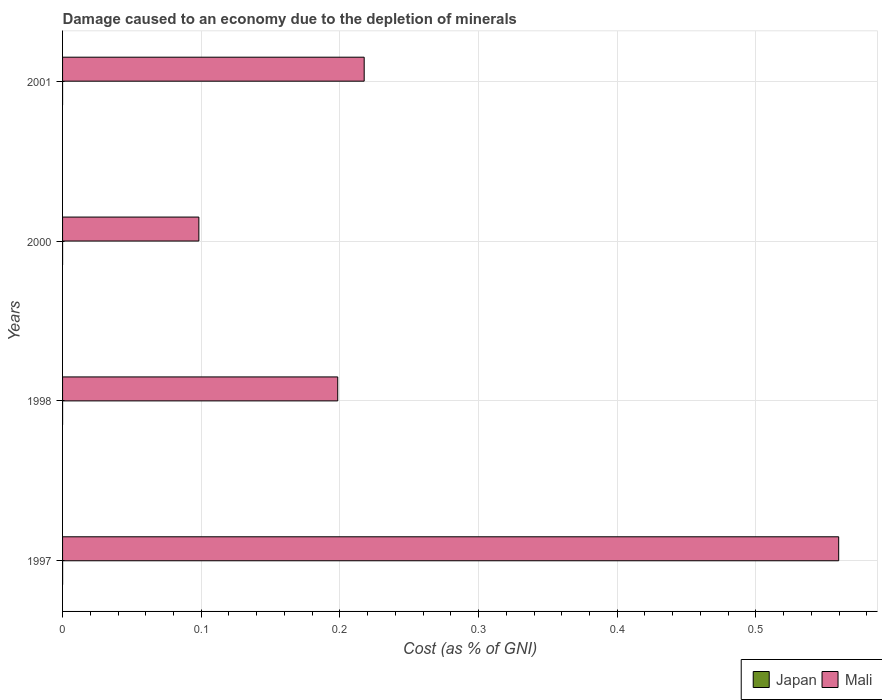How many groups of bars are there?
Your answer should be very brief. 4. Are the number of bars per tick equal to the number of legend labels?
Make the answer very short. Yes. What is the label of the 2nd group of bars from the top?
Your answer should be compact. 2000. What is the cost of damage caused due to the depletion of minerals in Japan in 1998?
Your answer should be very brief. 5.083030535406881e-6. Across all years, what is the maximum cost of damage caused due to the depletion of minerals in Japan?
Keep it short and to the point. 3.11135338085447e-5. Across all years, what is the minimum cost of damage caused due to the depletion of minerals in Japan?
Ensure brevity in your answer.  3.07197068481152e-6. In which year was the cost of damage caused due to the depletion of minerals in Mali maximum?
Provide a short and direct response. 1997. In which year was the cost of damage caused due to the depletion of minerals in Mali minimum?
Provide a short and direct response. 2000. What is the total cost of damage caused due to the depletion of minerals in Japan in the graph?
Provide a short and direct response. 4.6730321891409904e-5. What is the difference between the cost of damage caused due to the depletion of minerals in Mali in 1997 and that in 2001?
Ensure brevity in your answer.  0.34. What is the difference between the cost of damage caused due to the depletion of minerals in Japan in 1997 and the cost of damage caused due to the depletion of minerals in Mali in 2001?
Give a very brief answer. -0.22. What is the average cost of damage caused due to the depletion of minerals in Mali per year?
Provide a short and direct response. 0.27. In the year 1998, what is the difference between the cost of damage caused due to the depletion of minerals in Mali and cost of damage caused due to the depletion of minerals in Japan?
Provide a succinct answer. 0.2. In how many years, is the cost of damage caused due to the depletion of minerals in Japan greater than 0.06 %?
Give a very brief answer. 0. What is the ratio of the cost of damage caused due to the depletion of minerals in Japan in 1997 to that in 1998?
Offer a terse response. 6.12. Is the cost of damage caused due to the depletion of minerals in Mali in 1997 less than that in 2001?
Make the answer very short. No. What is the difference between the highest and the second highest cost of damage caused due to the depletion of minerals in Mali?
Provide a short and direct response. 0.34. What is the difference between the highest and the lowest cost of damage caused due to the depletion of minerals in Mali?
Offer a very short reply. 0.46. What does the 2nd bar from the top in 1998 represents?
Ensure brevity in your answer.  Japan. Are all the bars in the graph horizontal?
Give a very brief answer. Yes. How many years are there in the graph?
Make the answer very short. 4. How many legend labels are there?
Offer a very short reply. 2. How are the legend labels stacked?
Keep it short and to the point. Horizontal. What is the title of the graph?
Offer a very short reply. Damage caused to an economy due to the depletion of minerals. What is the label or title of the X-axis?
Keep it short and to the point. Cost (as % of GNI). What is the label or title of the Y-axis?
Make the answer very short. Years. What is the Cost (as % of GNI) in Japan in 1997?
Make the answer very short. 3.11135338085447e-5. What is the Cost (as % of GNI) of Mali in 1997?
Keep it short and to the point. 0.56. What is the Cost (as % of GNI) in Japan in 1998?
Your answer should be very brief. 5.083030535406881e-6. What is the Cost (as % of GNI) of Mali in 1998?
Ensure brevity in your answer.  0.2. What is the Cost (as % of GNI) in Japan in 2000?
Provide a succinct answer. 7.461786862646801e-6. What is the Cost (as % of GNI) in Mali in 2000?
Offer a terse response. 0.1. What is the Cost (as % of GNI) in Japan in 2001?
Provide a short and direct response. 3.07197068481152e-6. What is the Cost (as % of GNI) in Mali in 2001?
Make the answer very short. 0.22. Across all years, what is the maximum Cost (as % of GNI) in Japan?
Keep it short and to the point. 3.11135338085447e-5. Across all years, what is the maximum Cost (as % of GNI) of Mali?
Give a very brief answer. 0.56. Across all years, what is the minimum Cost (as % of GNI) in Japan?
Offer a terse response. 3.07197068481152e-6. Across all years, what is the minimum Cost (as % of GNI) of Mali?
Offer a terse response. 0.1. What is the total Cost (as % of GNI) of Mali in the graph?
Provide a succinct answer. 1.07. What is the difference between the Cost (as % of GNI) of Mali in 1997 and that in 1998?
Give a very brief answer. 0.36. What is the difference between the Cost (as % of GNI) of Mali in 1997 and that in 2000?
Your response must be concise. 0.46. What is the difference between the Cost (as % of GNI) in Mali in 1997 and that in 2001?
Offer a very short reply. 0.34. What is the difference between the Cost (as % of GNI) of Japan in 1998 and that in 2000?
Your response must be concise. -0. What is the difference between the Cost (as % of GNI) of Mali in 1998 and that in 2000?
Your answer should be compact. 0.1. What is the difference between the Cost (as % of GNI) of Mali in 1998 and that in 2001?
Your answer should be compact. -0.02. What is the difference between the Cost (as % of GNI) of Japan in 2000 and that in 2001?
Offer a terse response. 0. What is the difference between the Cost (as % of GNI) of Mali in 2000 and that in 2001?
Your response must be concise. -0.12. What is the difference between the Cost (as % of GNI) in Japan in 1997 and the Cost (as % of GNI) in Mali in 1998?
Provide a succinct answer. -0.2. What is the difference between the Cost (as % of GNI) of Japan in 1997 and the Cost (as % of GNI) of Mali in 2000?
Your answer should be very brief. -0.1. What is the difference between the Cost (as % of GNI) of Japan in 1997 and the Cost (as % of GNI) of Mali in 2001?
Your response must be concise. -0.22. What is the difference between the Cost (as % of GNI) in Japan in 1998 and the Cost (as % of GNI) in Mali in 2000?
Your answer should be very brief. -0.1. What is the difference between the Cost (as % of GNI) of Japan in 1998 and the Cost (as % of GNI) of Mali in 2001?
Your answer should be very brief. -0.22. What is the difference between the Cost (as % of GNI) in Japan in 2000 and the Cost (as % of GNI) in Mali in 2001?
Keep it short and to the point. -0.22. What is the average Cost (as % of GNI) of Japan per year?
Your answer should be very brief. 0. What is the average Cost (as % of GNI) in Mali per year?
Give a very brief answer. 0.27. In the year 1997, what is the difference between the Cost (as % of GNI) of Japan and Cost (as % of GNI) of Mali?
Provide a short and direct response. -0.56. In the year 1998, what is the difference between the Cost (as % of GNI) in Japan and Cost (as % of GNI) in Mali?
Offer a very short reply. -0.2. In the year 2000, what is the difference between the Cost (as % of GNI) of Japan and Cost (as % of GNI) of Mali?
Make the answer very short. -0.1. In the year 2001, what is the difference between the Cost (as % of GNI) of Japan and Cost (as % of GNI) of Mali?
Give a very brief answer. -0.22. What is the ratio of the Cost (as % of GNI) of Japan in 1997 to that in 1998?
Your response must be concise. 6.12. What is the ratio of the Cost (as % of GNI) in Mali in 1997 to that in 1998?
Provide a short and direct response. 2.82. What is the ratio of the Cost (as % of GNI) of Japan in 1997 to that in 2000?
Give a very brief answer. 4.17. What is the ratio of the Cost (as % of GNI) of Mali in 1997 to that in 2000?
Provide a short and direct response. 5.69. What is the ratio of the Cost (as % of GNI) in Japan in 1997 to that in 2001?
Keep it short and to the point. 10.13. What is the ratio of the Cost (as % of GNI) of Mali in 1997 to that in 2001?
Ensure brevity in your answer.  2.57. What is the ratio of the Cost (as % of GNI) in Japan in 1998 to that in 2000?
Provide a succinct answer. 0.68. What is the ratio of the Cost (as % of GNI) in Mali in 1998 to that in 2000?
Your response must be concise. 2.02. What is the ratio of the Cost (as % of GNI) of Japan in 1998 to that in 2001?
Offer a very short reply. 1.65. What is the ratio of the Cost (as % of GNI) of Mali in 1998 to that in 2001?
Ensure brevity in your answer.  0.91. What is the ratio of the Cost (as % of GNI) in Japan in 2000 to that in 2001?
Keep it short and to the point. 2.43. What is the ratio of the Cost (as % of GNI) of Mali in 2000 to that in 2001?
Your response must be concise. 0.45. What is the difference between the highest and the second highest Cost (as % of GNI) in Japan?
Provide a short and direct response. 0. What is the difference between the highest and the second highest Cost (as % of GNI) of Mali?
Keep it short and to the point. 0.34. What is the difference between the highest and the lowest Cost (as % of GNI) in Mali?
Offer a very short reply. 0.46. 